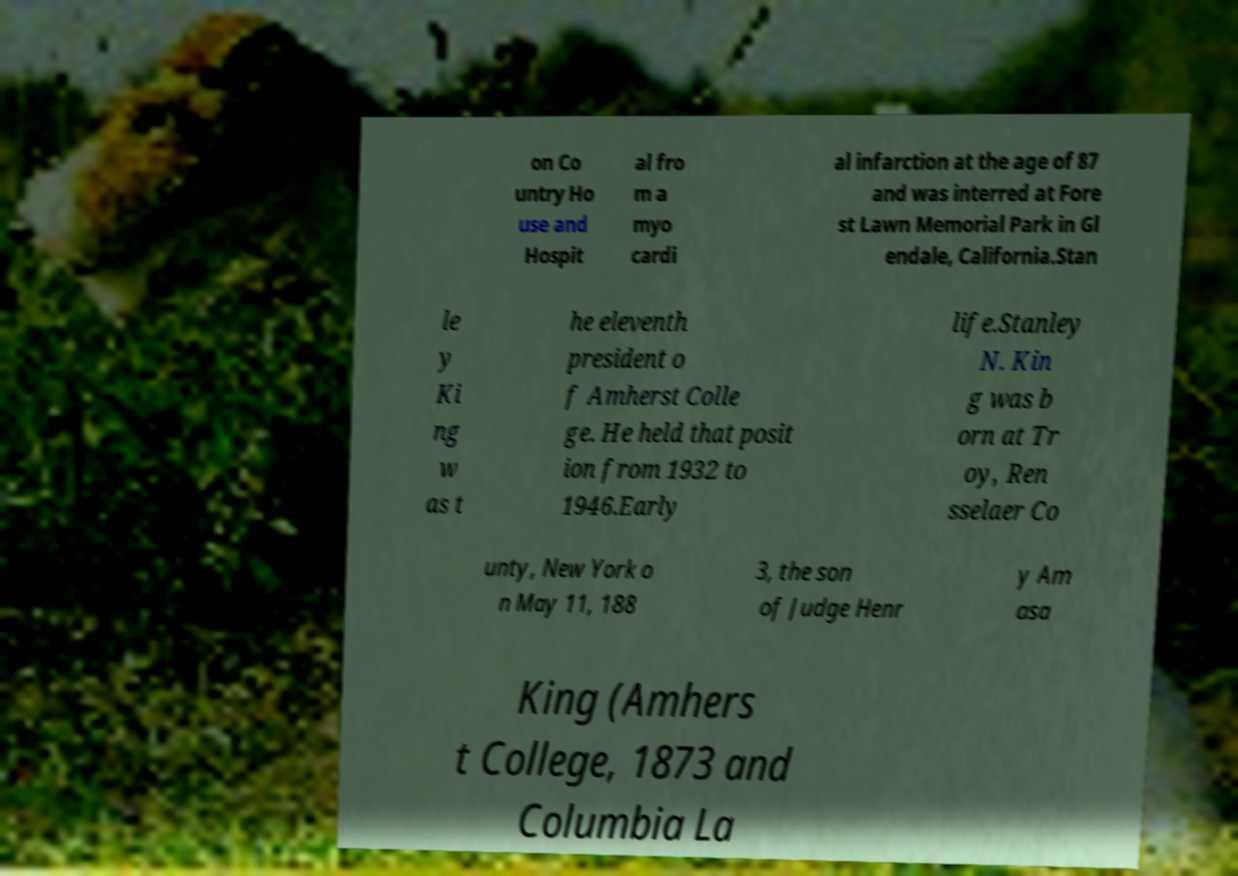Could you assist in decoding the text presented in this image and type it out clearly? on Co untry Ho use and Hospit al fro m a myo cardi al infarction at the age of 87 and was interred at Fore st Lawn Memorial Park in Gl endale, California.Stan le y Ki ng w as t he eleventh president o f Amherst Colle ge. He held that posit ion from 1932 to 1946.Early life.Stanley N. Kin g was b orn at Tr oy, Ren sselaer Co unty, New York o n May 11, 188 3, the son of Judge Henr y Am asa King (Amhers t College, 1873 and Columbia La 